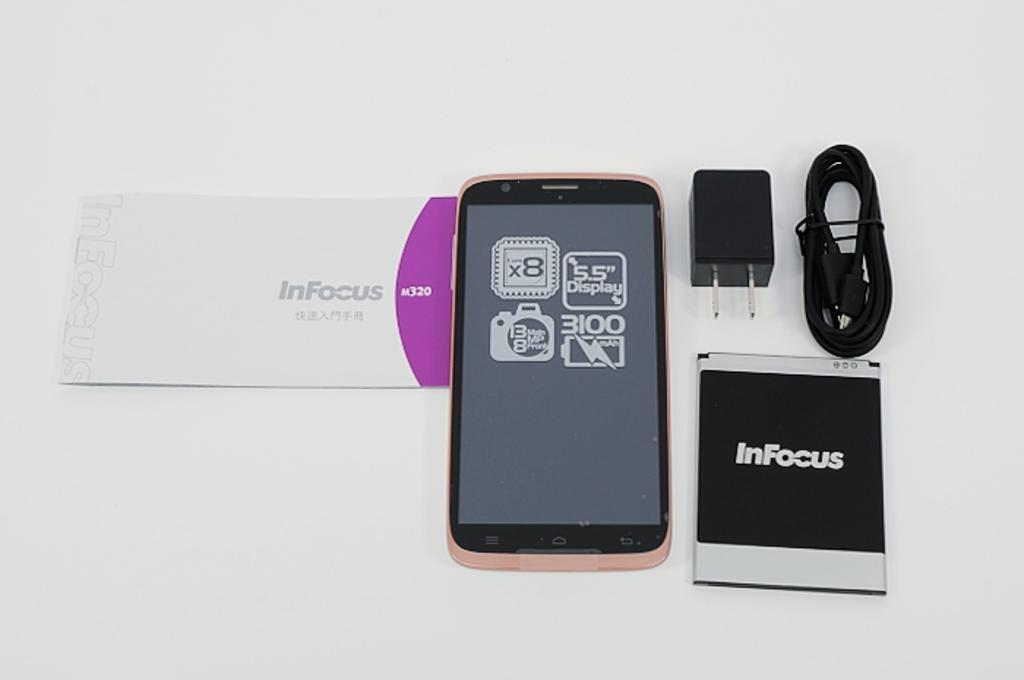Provide a one-sentence caption for the provided image. An InFocus cellphone and charger lay on a white surface. 